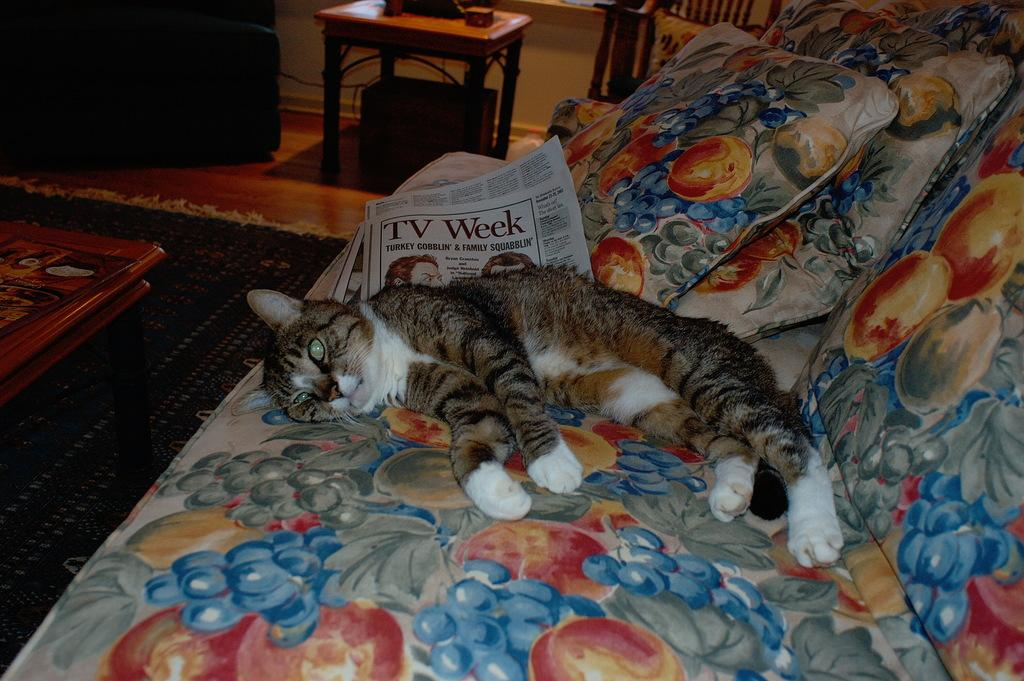What type of animal is in the image? There is a cat in the image. What is the cat doing in the image? The cat is sleeping on a sofa. What can be inferred about the setting of the image? The setting appears to be a living room. What type of iron is visible in the image? There is no iron present in the image. Can you see an airplane in the image? No, there is no airplane in the image. 